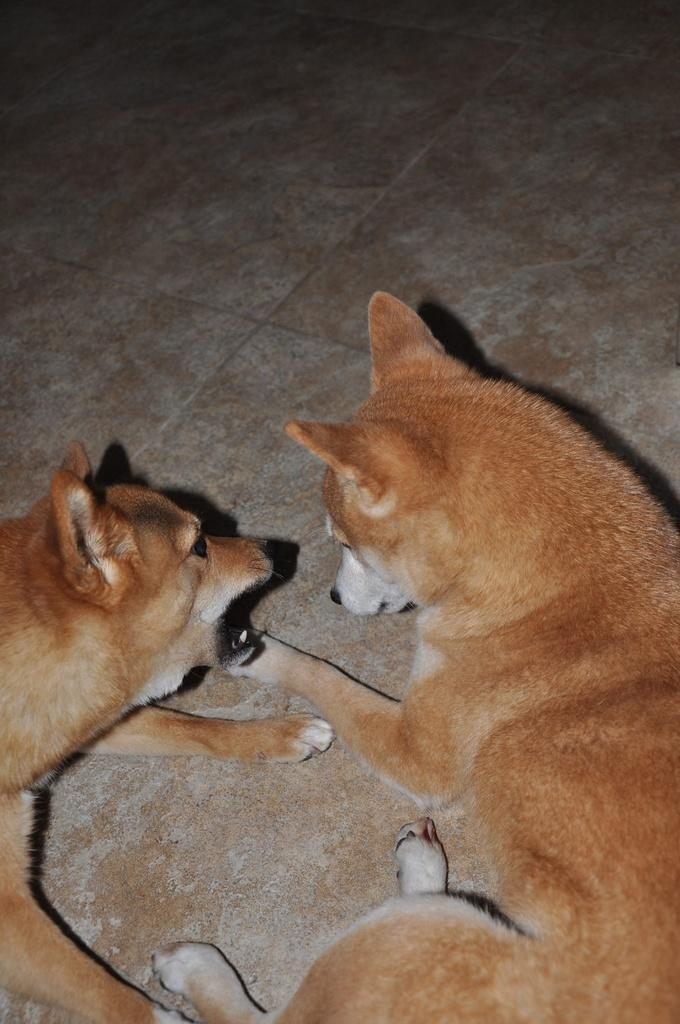How many dogs are in the image? There are two brown color dogs in the image. What is the color of the dogs? The dogs are brown. Where are the dogs located in the image? The dogs are on the floor. What type of stocking is the dog wearing on its front leg in the image? There are no stockings present on the dogs in the image. What is the dog doing with the scissors in the image? There are no scissors present in the image. 